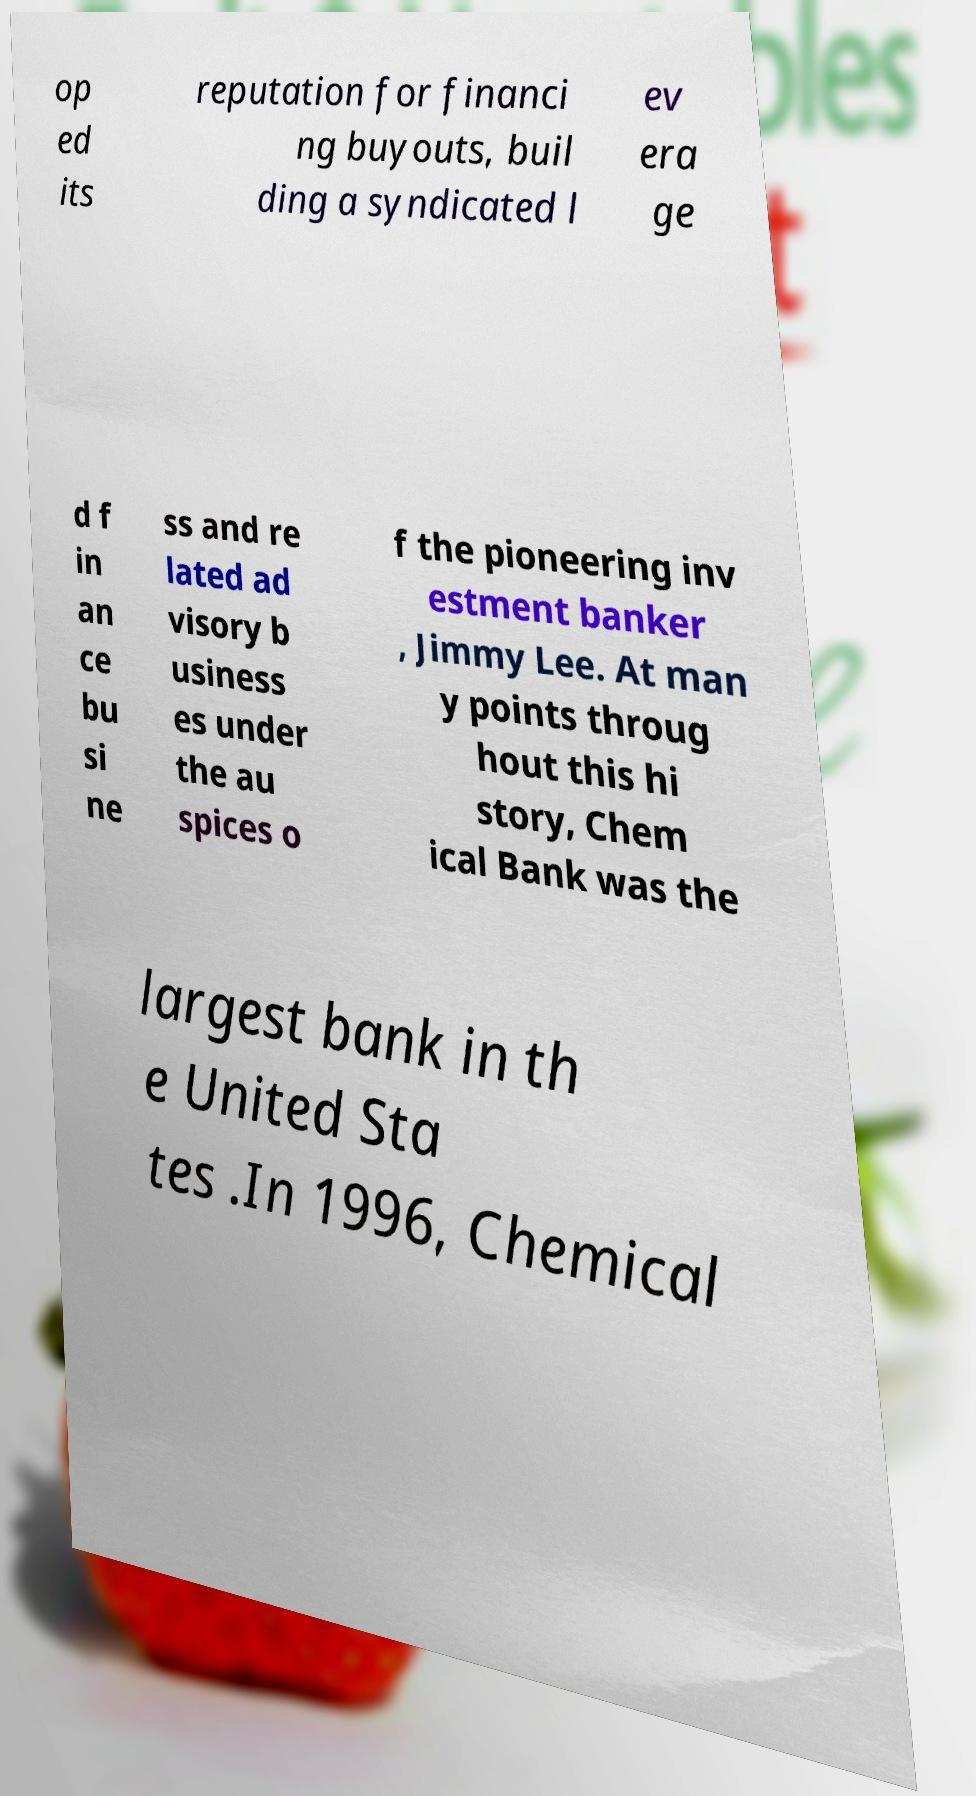For documentation purposes, I need the text within this image transcribed. Could you provide that? op ed its reputation for financi ng buyouts, buil ding a syndicated l ev era ge d f in an ce bu si ne ss and re lated ad visory b usiness es under the au spices o f the pioneering inv estment banker , Jimmy Lee. At man y points throug hout this hi story, Chem ical Bank was the largest bank in th e United Sta tes .In 1996, Chemical 